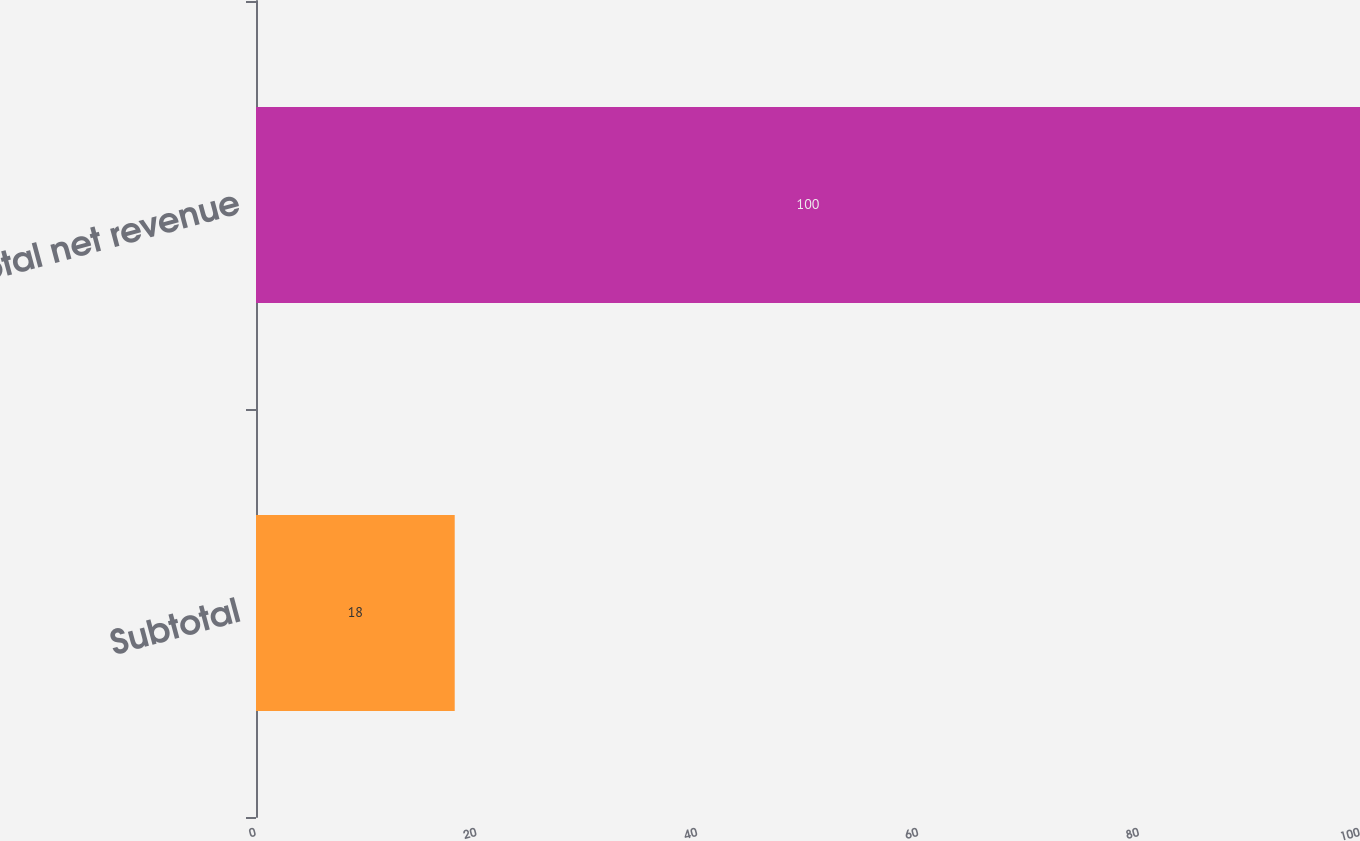<chart> <loc_0><loc_0><loc_500><loc_500><bar_chart><fcel>Subtotal<fcel>Total net revenue<nl><fcel>18<fcel>100<nl></chart> 